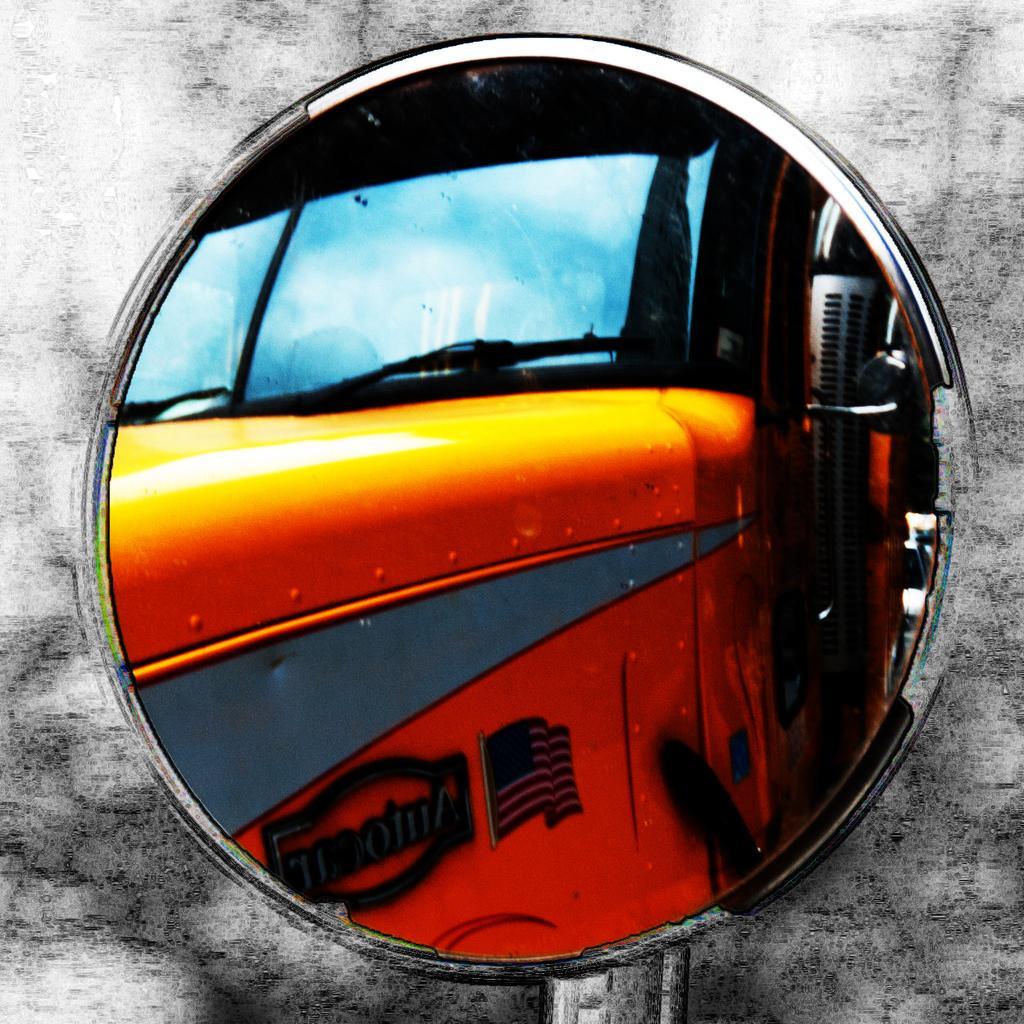Can you describe this image briefly? In this picture we can observe a mirror. Through this mirror we can see a yellow color vehicle and a sky with clouds. The background is in white and black color. 